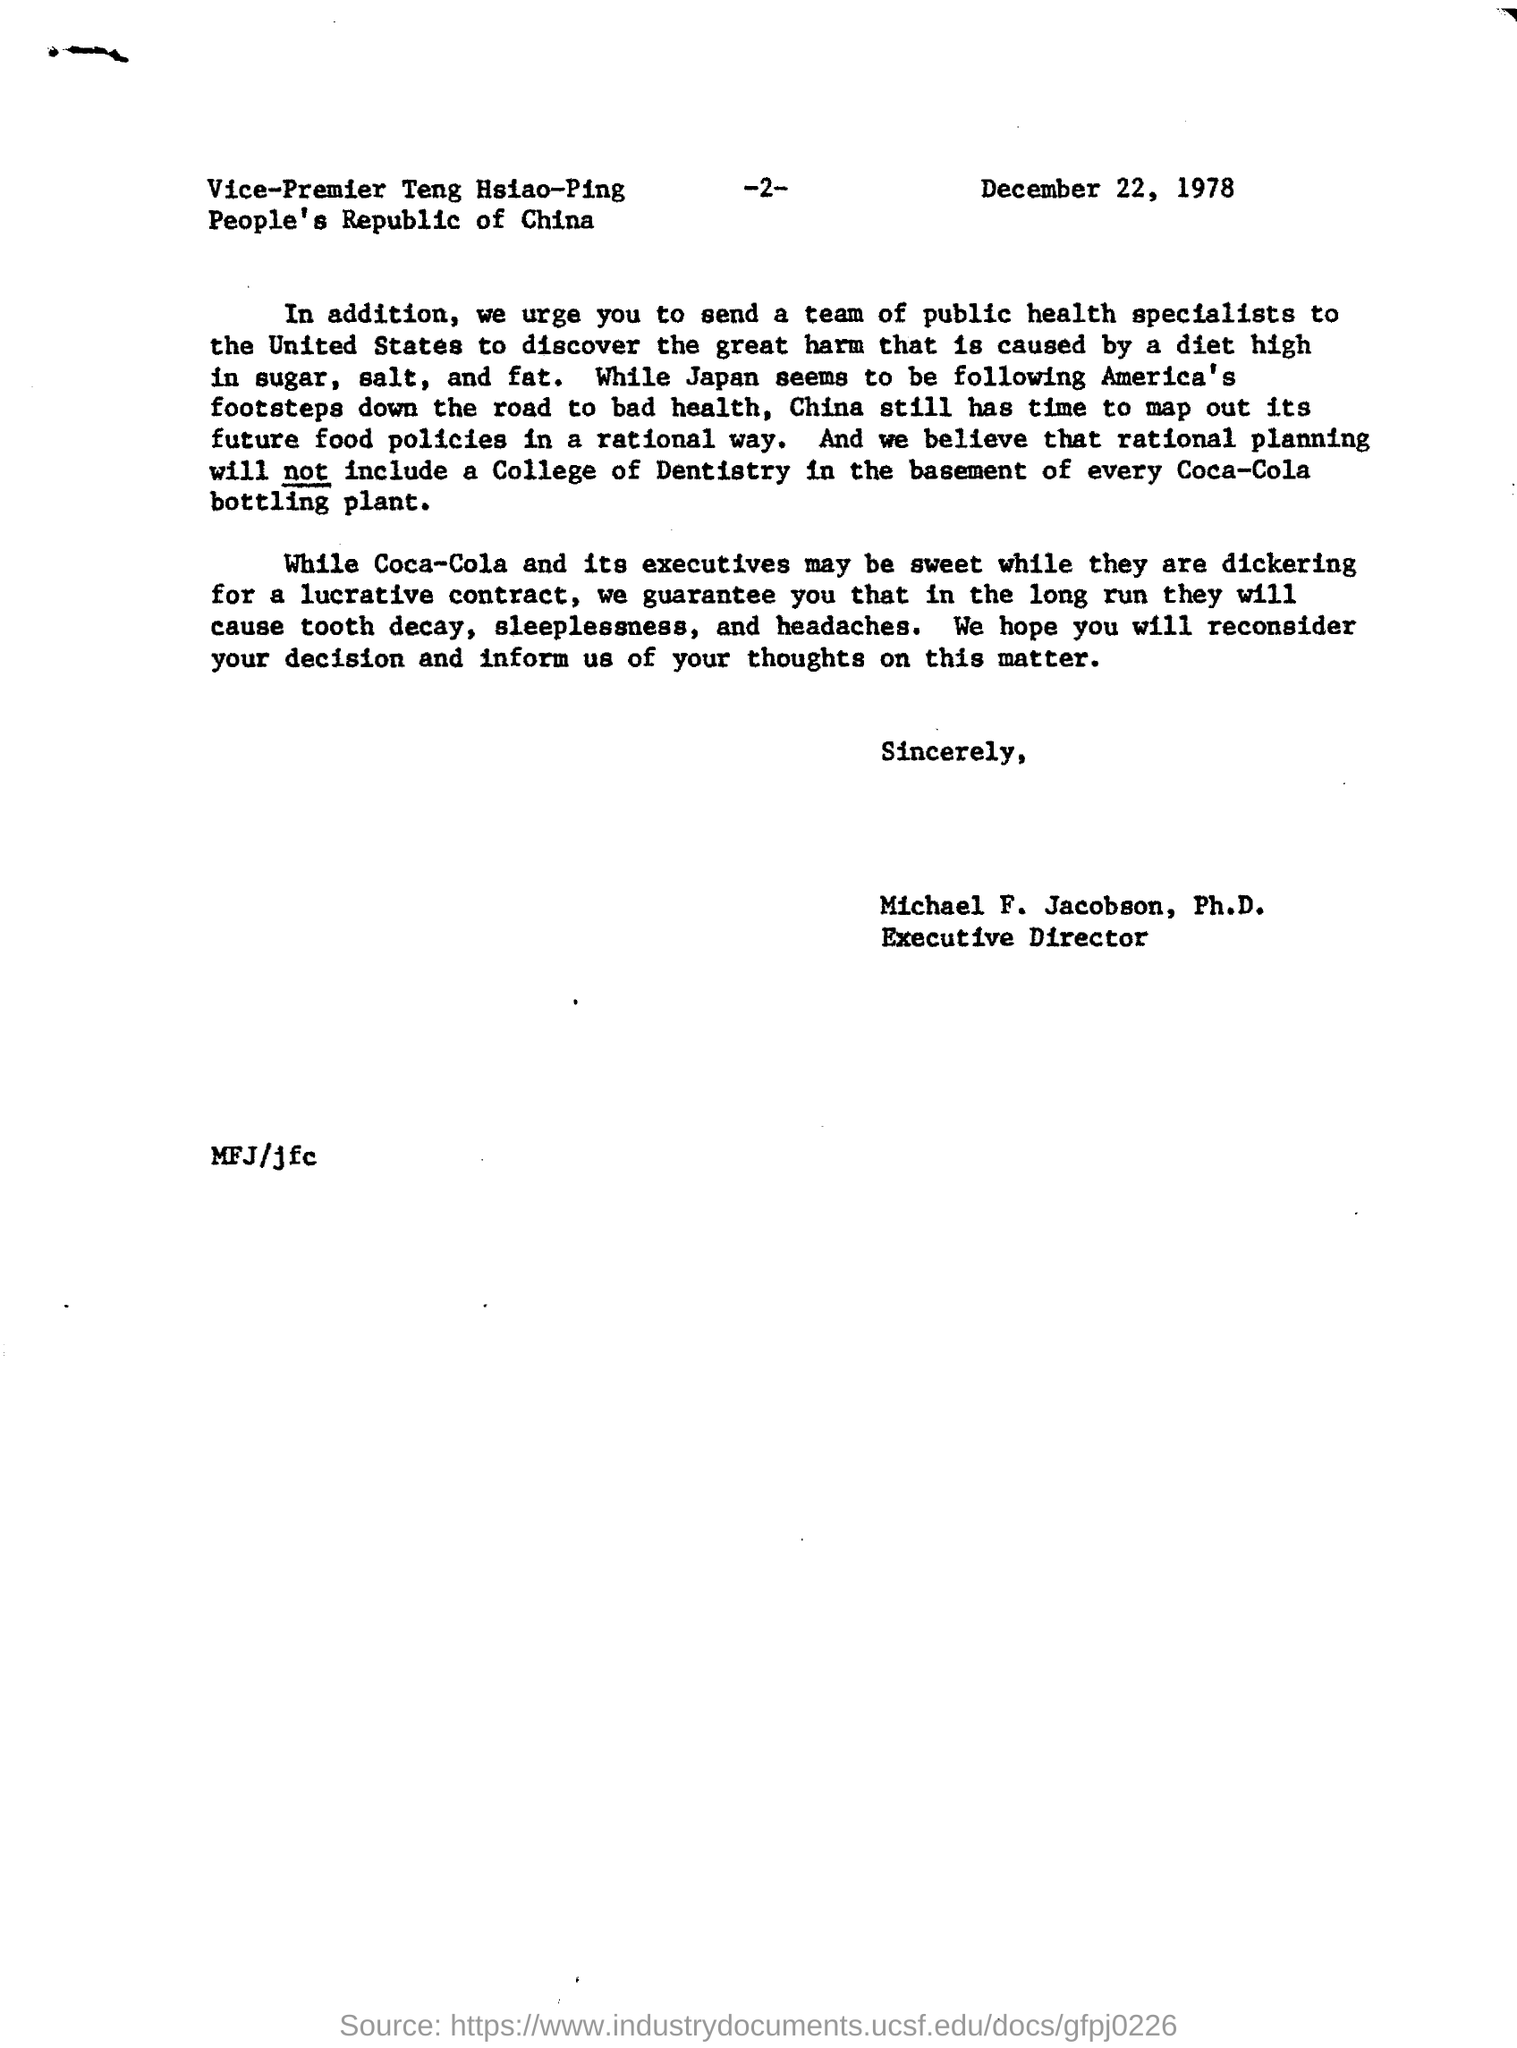Who seems to be following America's footsteps?
Offer a terse response. Japan. 